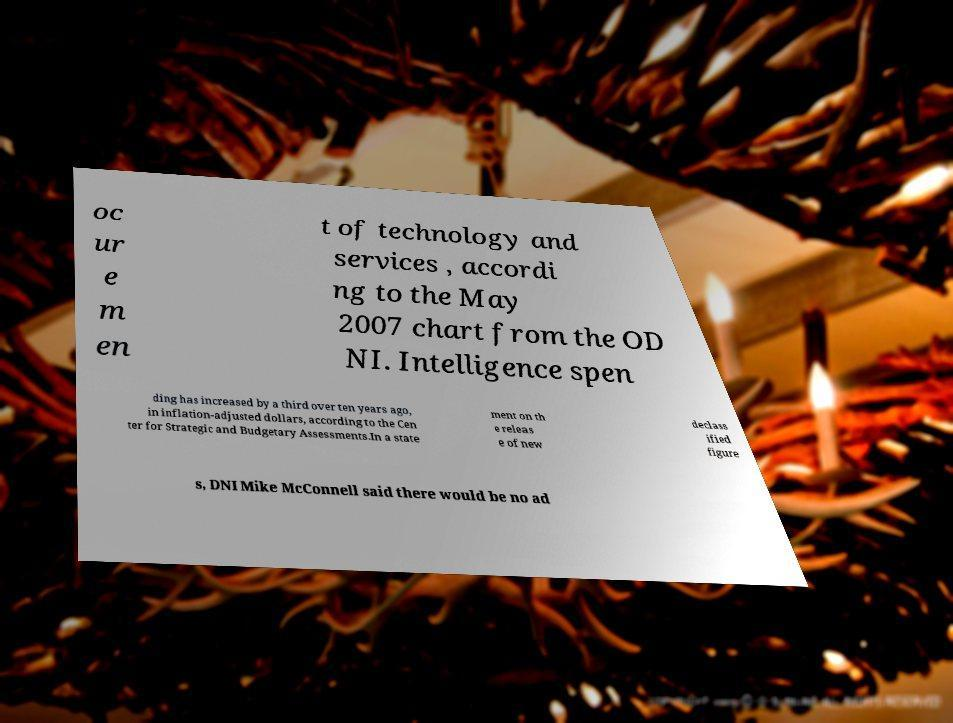Could you extract and type out the text from this image? oc ur e m en t of technology and services , accordi ng to the May 2007 chart from the OD NI. Intelligence spen ding has increased by a third over ten years ago, in inflation-adjusted dollars, according to the Cen ter for Strategic and Budgetary Assessments.In a state ment on th e releas e of new declass ified figure s, DNI Mike McConnell said there would be no ad 